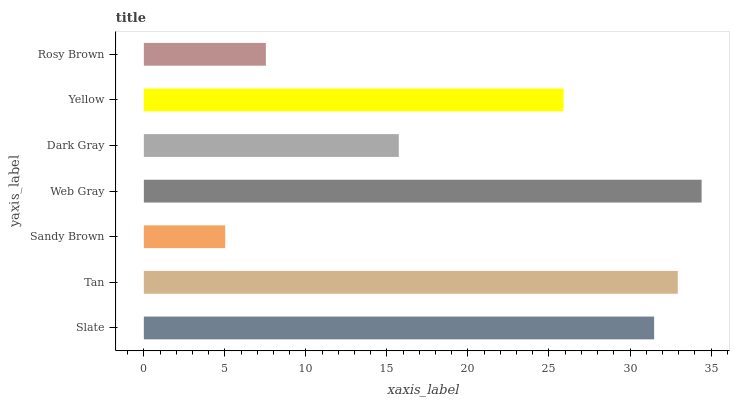Is Sandy Brown the minimum?
Answer yes or no. Yes. Is Web Gray the maximum?
Answer yes or no. Yes. Is Tan the minimum?
Answer yes or no. No. Is Tan the maximum?
Answer yes or no. No. Is Tan greater than Slate?
Answer yes or no. Yes. Is Slate less than Tan?
Answer yes or no. Yes. Is Slate greater than Tan?
Answer yes or no. No. Is Tan less than Slate?
Answer yes or no. No. Is Yellow the high median?
Answer yes or no. Yes. Is Yellow the low median?
Answer yes or no. Yes. Is Dark Gray the high median?
Answer yes or no. No. Is Dark Gray the low median?
Answer yes or no. No. 